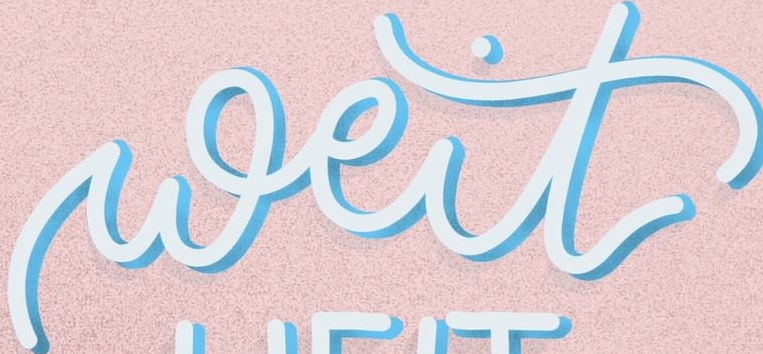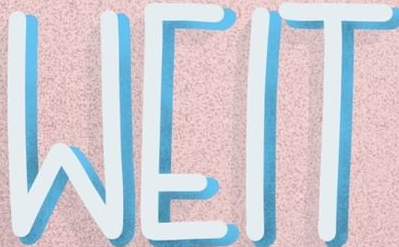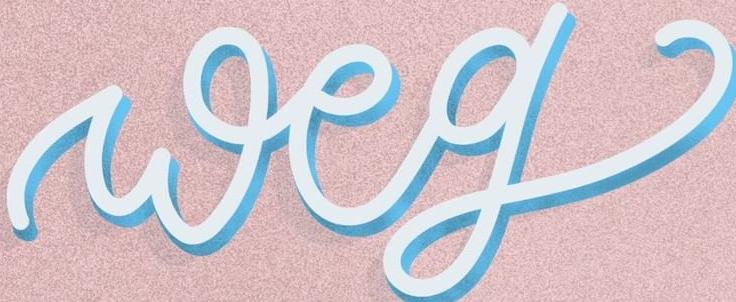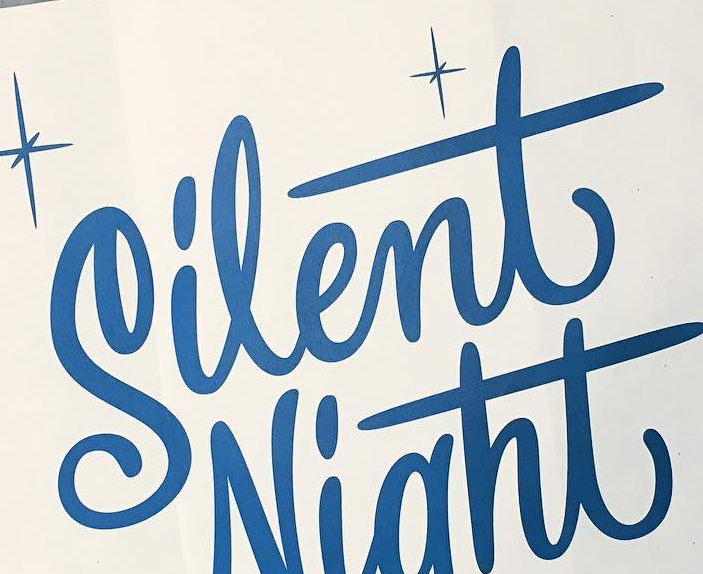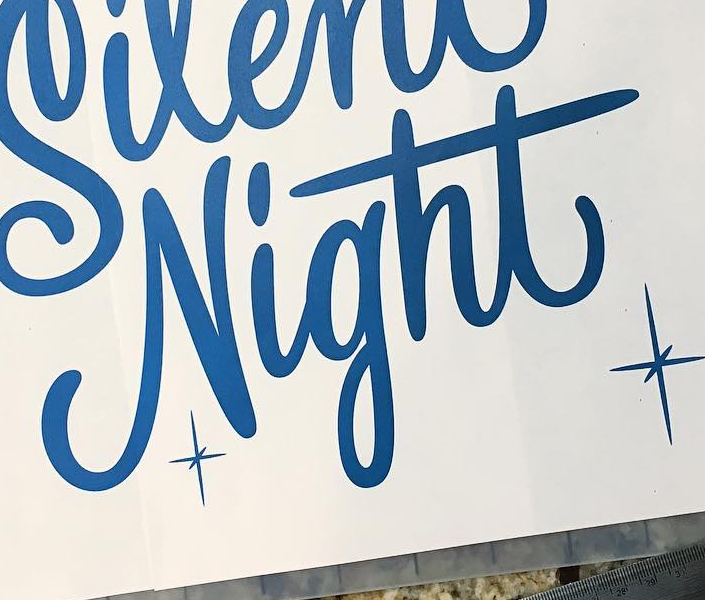What words are shown in these images in order, separated by a semicolon? weit; WEIT; weg; Silent; Night 